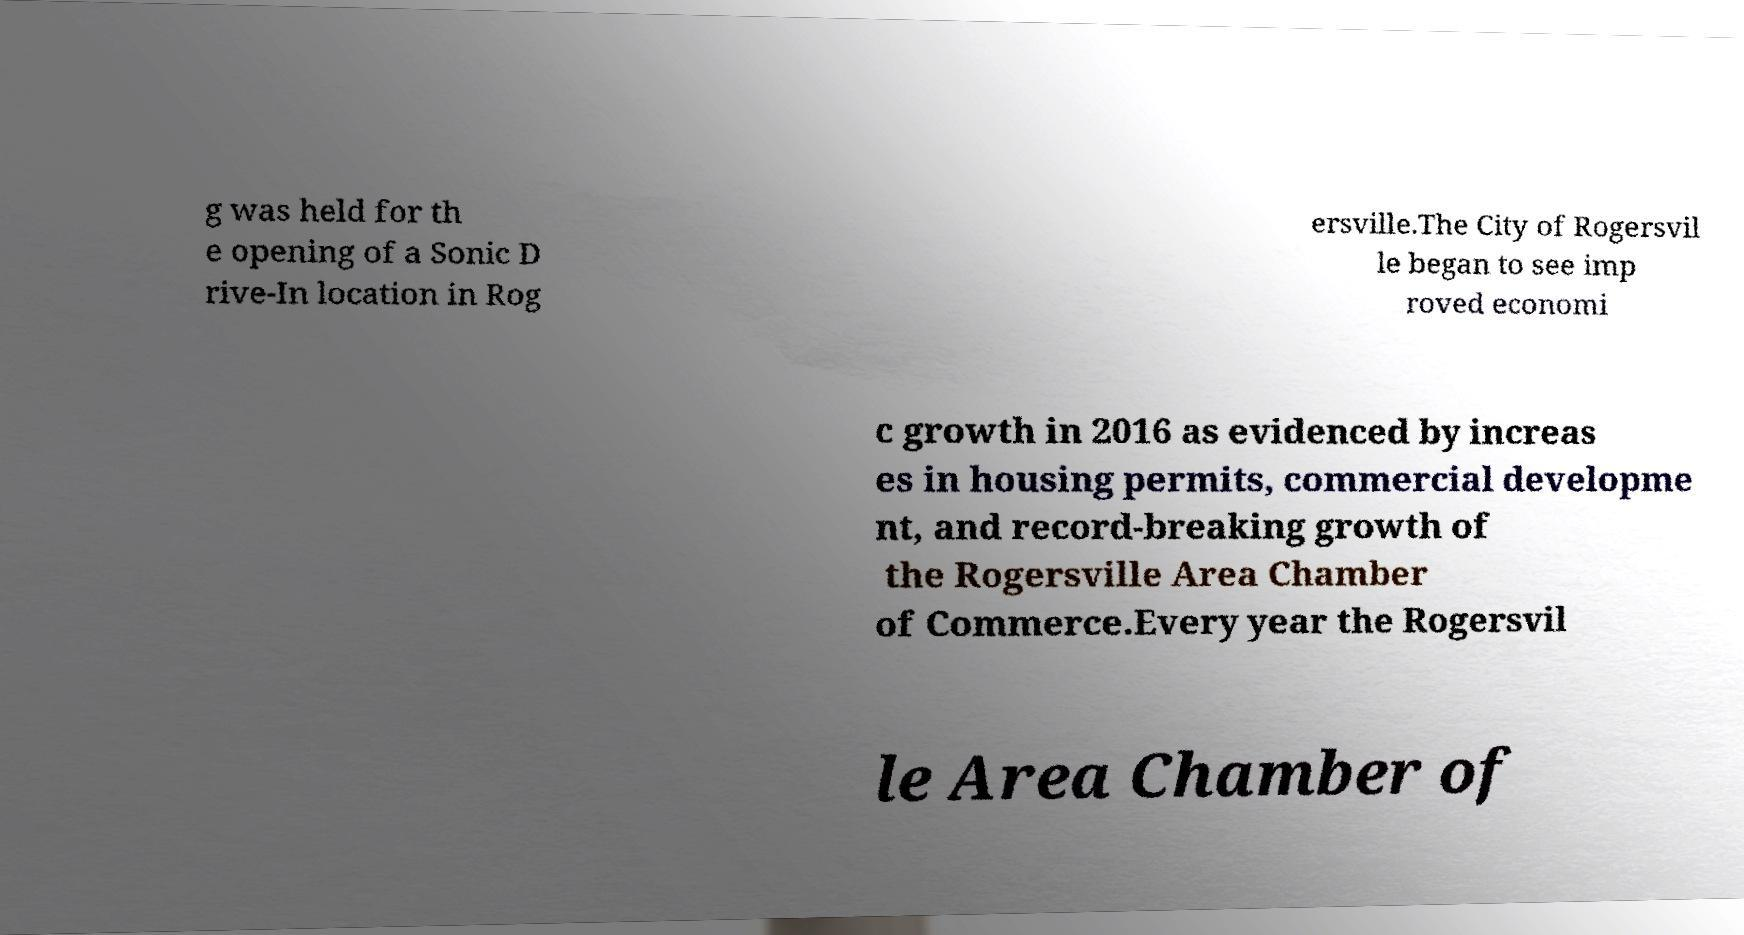There's text embedded in this image that I need extracted. Can you transcribe it verbatim? g was held for th e opening of a Sonic D rive-In location in Rog ersville.The City of Rogersvil le began to see imp roved economi c growth in 2016 as evidenced by increas es in housing permits, commercial developme nt, and record-breaking growth of the Rogersville Area Chamber of Commerce.Every year the Rogersvil le Area Chamber of 